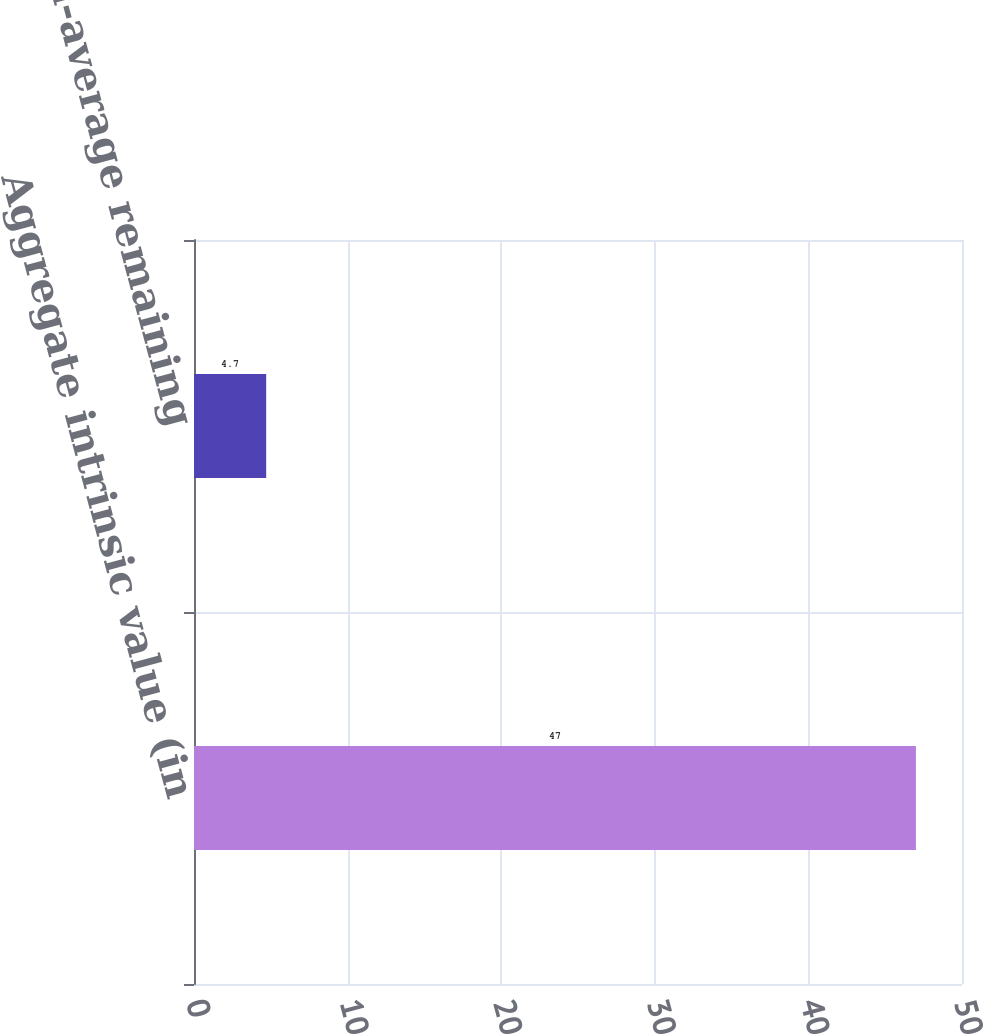Convert chart to OTSL. <chart><loc_0><loc_0><loc_500><loc_500><bar_chart><fcel>Aggregate intrinsic value (in<fcel>Weighted-average remaining<nl><fcel>47<fcel>4.7<nl></chart> 